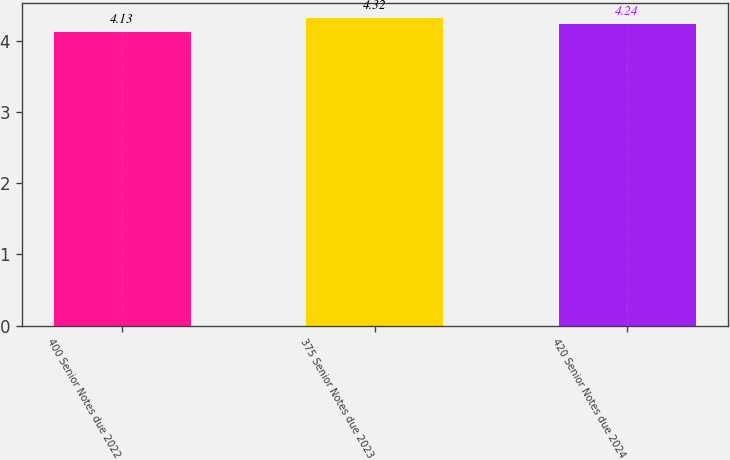<chart> <loc_0><loc_0><loc_500><loc_500><bar_chart><fcel>400 Senior Notes due 2022<fcel>375 Senior Notes due 2023<fcel>420 Senior Notes due 2024<nl><fcel>4.13<fcel>4.32<fcel>4.24<nl></chart> 